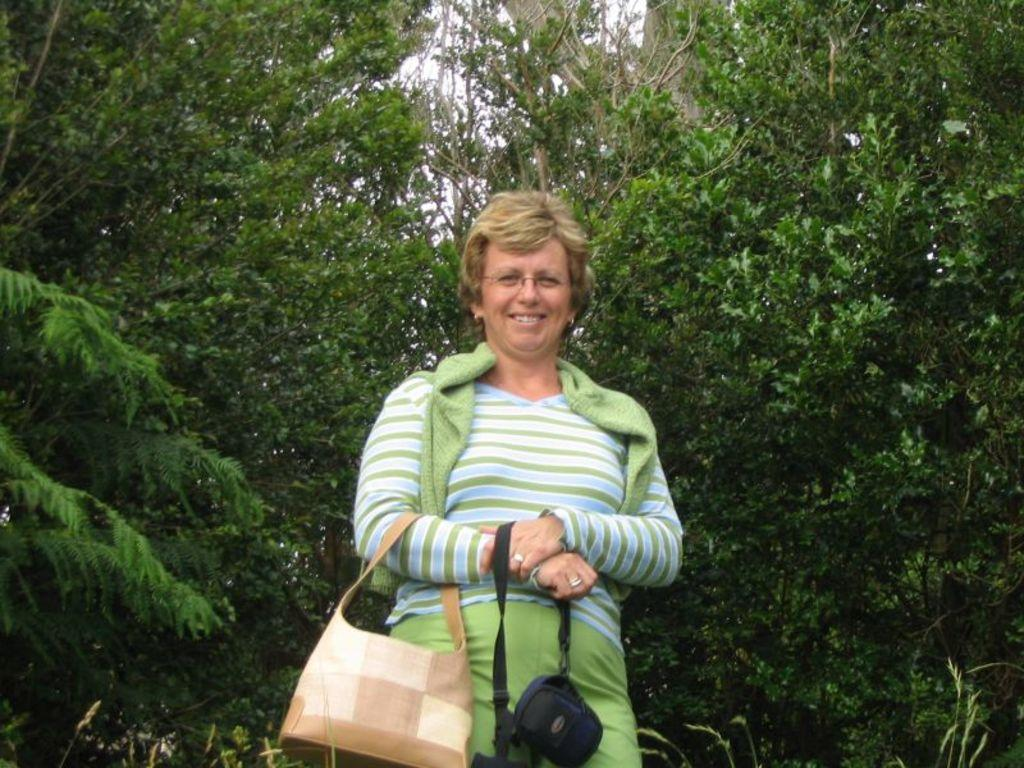Who is present in the image? There is a woman in the image. What is the woman doing in the image? The woman is standing in the image. What is the woman holding or carrying in the image? The woman is carrying a handbag in the image. What can be seen in the background of the image? There are trees in the background of the image. What type of test is the woman taking in the image? There is no test present in the image; the woman is simply standing and carrying a handbag. 